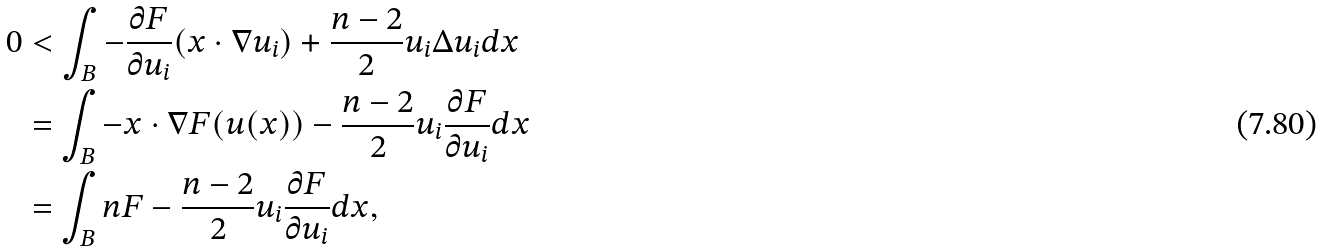Convert formula to latex. <formula><loc_0><loc_0><loc_500><loc_500>0 & < \int _ { B } - \frac { \partial F } { \partial u _ { i } } ( x \cdot \nabla u _ { i } ) + \frac { n - 2 } { 2 } u _ { i } \Delta u _ { i } d x \\ & = \int _ { B } - x \cdot \nabla F ( u ( x ) ) - \frac { n - 2 } { 2 } u _ { i } \frac { \partial F } { \partial u _ { i } } d x \\ & = \int _ { B } n F - \frac { n - 2 } { 2 } u _ { i } \frac { \partial F } { \partial u _ { i } } d x ,</formula> 